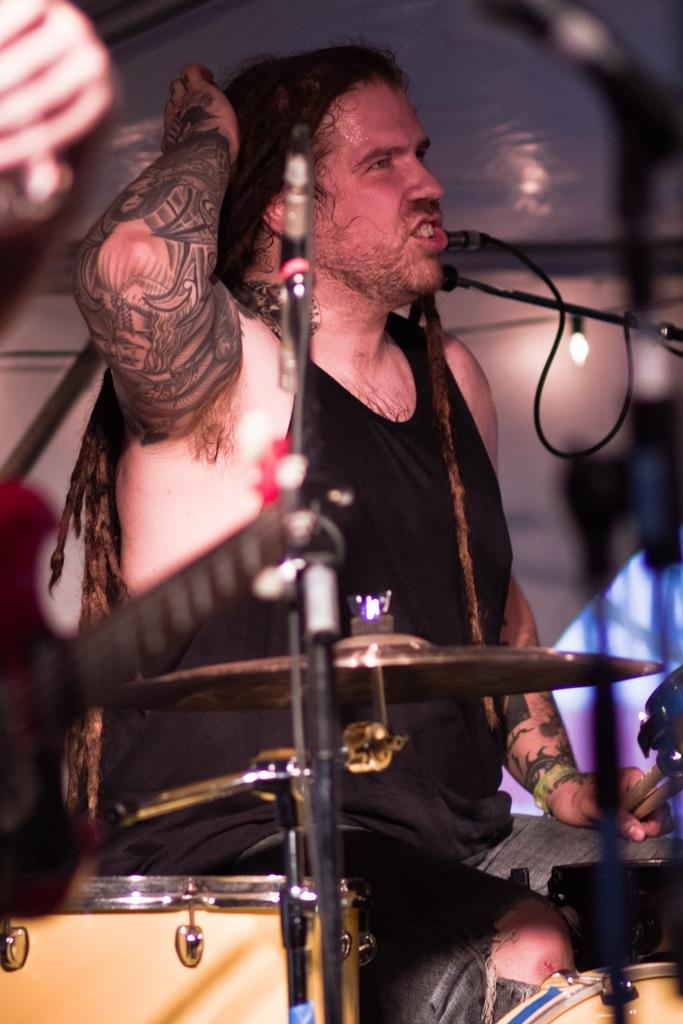What is the man in the image doing? There is a man sitting on a chair in the image. What objects are in front of the man? There are musical instruments in front of the man. What reason does the man have for needing to land on the moon in the image? There is no reference to the moon or any reason for needing to land on it in the image. 